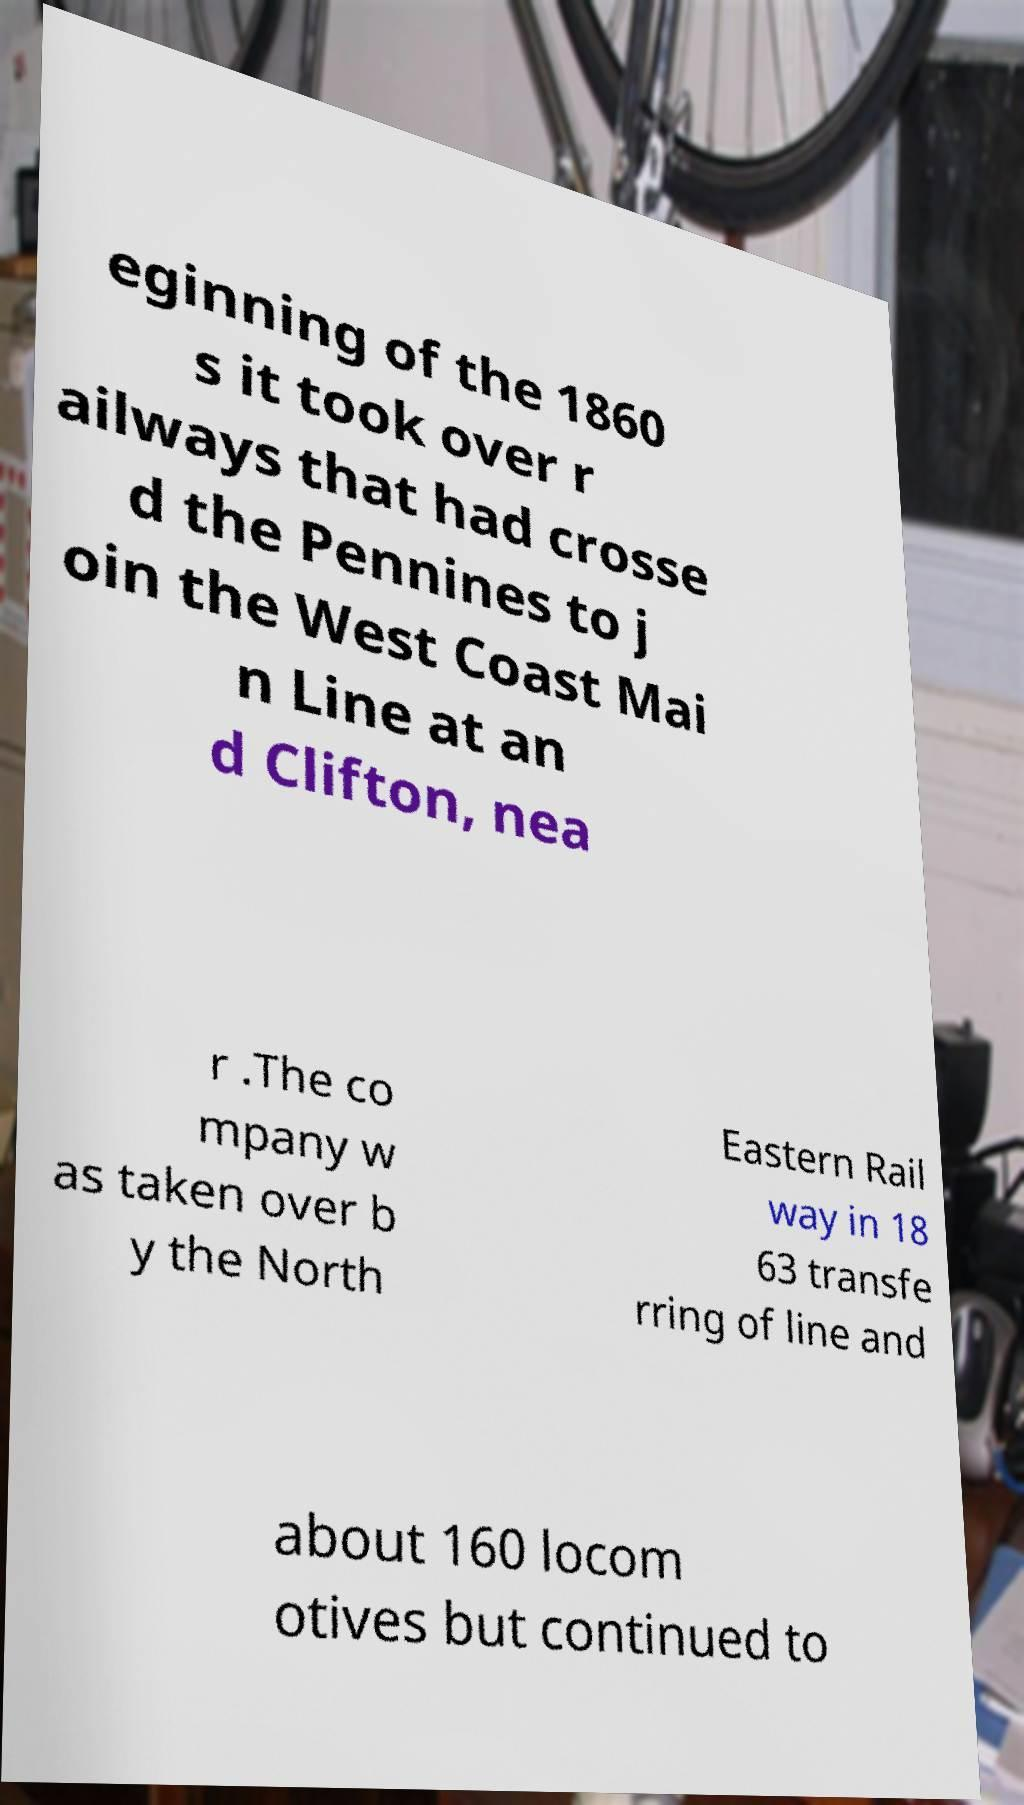Could you extract and type out the text from this image? eginning of the 1860 s it took over r ailways that had crosse d the Pennines to j oin the West Coast Mai n Line at an d Clifton, nea r .The co mpany w as taken over b y the North Eastern Rail way in 18 63 transfe rring of line and about 160 locom otives but continued to 